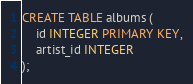Convert code to text. <code><loc_0><loc_0><loc_500><loc_500><_SQL_>CREATE TABLE albums (
	id INTEGER PRIMARY KEY,
	artist_id INTEGER
);</code> 